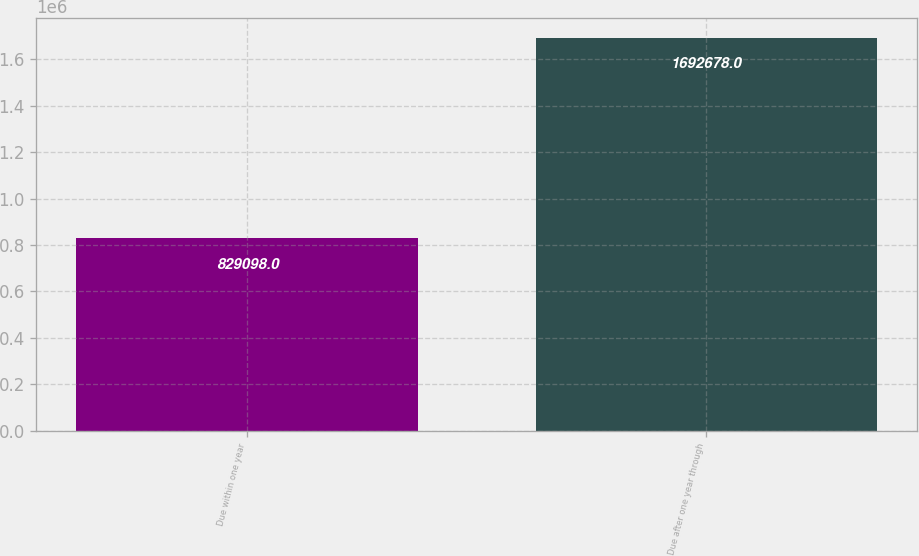Convert chart. <chart><loc_0><loc_0><loc_500><loc_500><bar_chart><fcel>Due within one year<fcel>Due after one year through<nl><fcel>829098<fcel>1.69268e+06<nl></chart> 